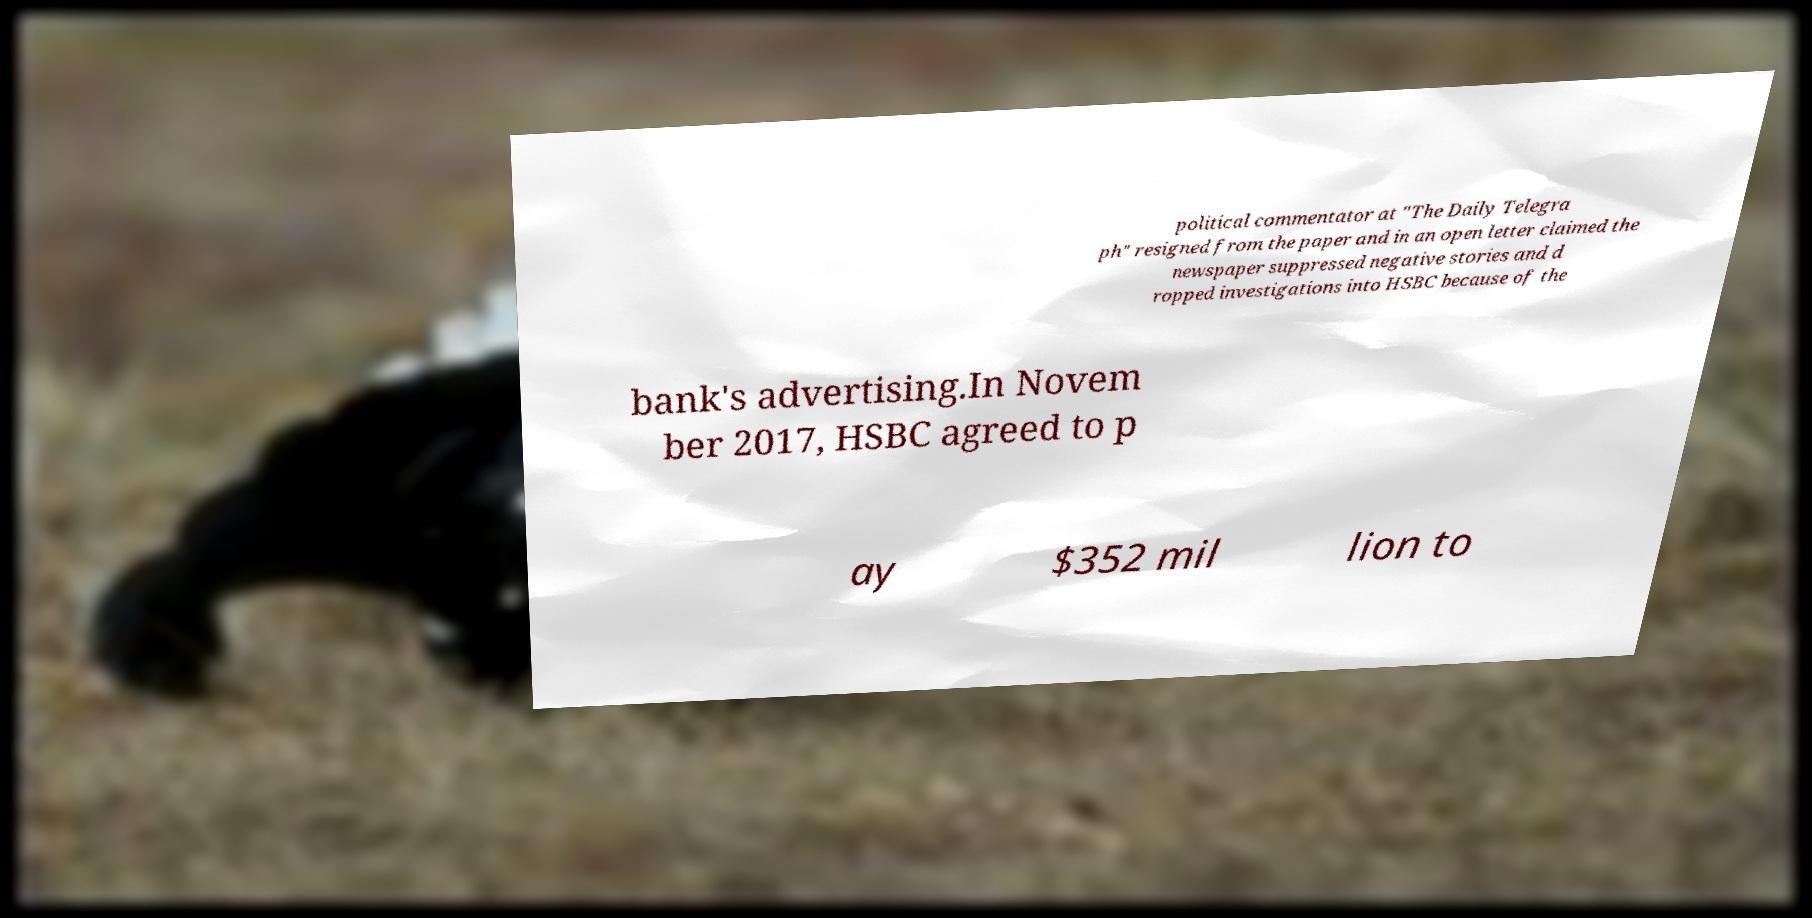Can you accurately transcribe the text from the provided image for me? political commentator at "The Daily Telegra ph" resigned from the paper and in an open letter claimed the newspaper suppressed negative stories and d ropped investigations into HSBC because of the bank's advertising.In Novem ber 2017, HSBC agreed to p ay $352 mil lion to 